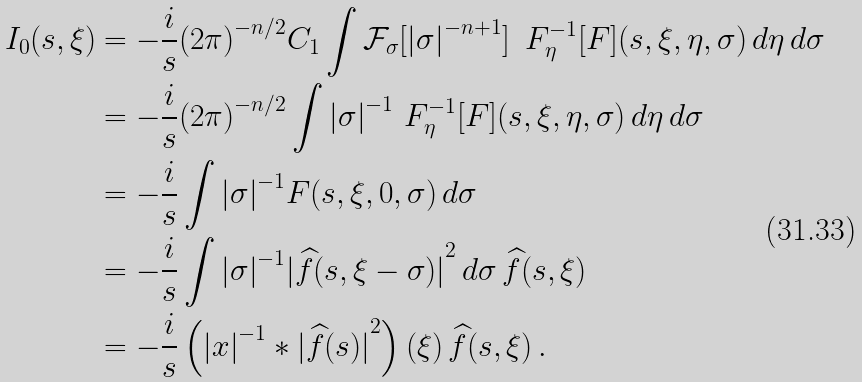Convert formula to latex. <formula><loc_0><loc_0><loc_500><loc_500>I _ { 0 } ( s , \xi ) & = - \frac { i } { s } { ( 2 \pi ) } ^ { - n / 2 } C _ { 1 } \int \mathcal { F } _ { \sigma } [ { | \sigma | } ^ { - n + 1 } ] \, \ F _ { \eta } ^ { - 1 } [ F ] ( s , \xi , \eta , \sigma ) \, d \eta \, d \sigma \\ & = - \frac { i } { s } { ( 2 \pi ) } ^ { - n / 2 } \int { | \sigma | } ^ { - 1 } \ F _ { \eta } ^ { - 1 } [ F ] ( s , \xi , \eta , \sigma ) \, d \eta \, d \sigma \\ & = - \frac { i } { s } \int { | \sigma | } ^ { - 1 } F ( s , \xi , 0 , \sigma ) \, d \sigma \\ & = - \frac { i } { s } \int { | \sigma | } ^ { - 1 } { | \widehat { f } ( s , \xi - \sigma ) | } ^ { 2 } \, d \sigma \, \widehat { f } ( s , \xi ) \\ & = - \frac { i } { s } \left ( { | x | } ^ { - 1 } \ast { | \widehat { f } ( s ) | } ^ { 2 } \right ) ( \xi ) \, \widehat { f } ( s , \xi ) \, .</formula> 